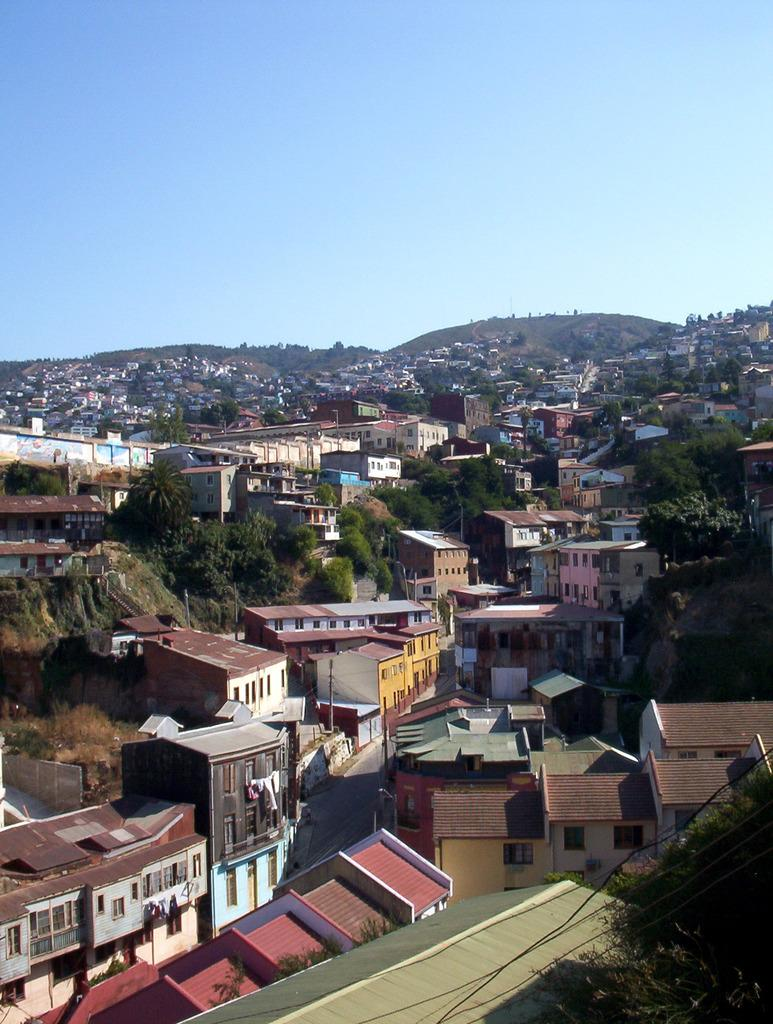What type of structures are visible in the image? There is a group of buildings with roofs in the image. What other natural elements can be seen in the image? There are trees and mountains in the image. What is visible in the background of the image? The sky is visible in the image. Where is the woman taking her recess in the image? There is no woman or recess present in the image. What type of waste is being disposed of in the image? There is no waste disposal present in the image. 